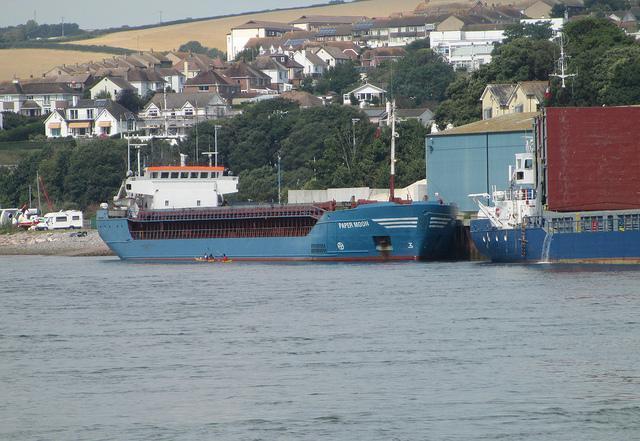How many boats are visible?
Give a very brief answer. 2. How many toy mice have a sign?
Give a very brief answer. 0. 